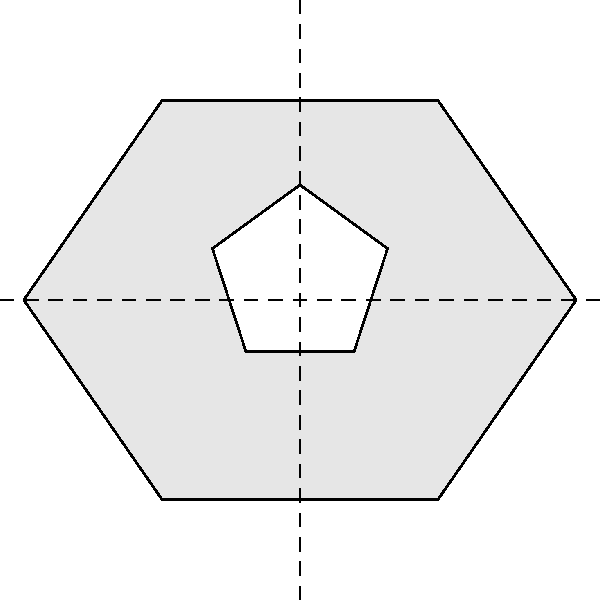As an officer committed to community service, you're analyzing the symmetry of a new police badge design. The badge is a vertically elongated hexagon with a white star in the center. What is the order of the symmetry group for this badge design? To determine the order of the symmetry group, we need to identify all symmetry operations that leave the badge unchanged:

1. Rotational symmetry:
   - The badge has 2-fold rotational symmetry (180° rotation).

2. Reflection symmetry:
   - There are two lines of reflection:
     a. Vertical line through the center
     b. Horizontal line through the center

3. Identity transformation:
   - Leaving the badge unchanged is also a symmetry operation.

To calculate the order of the symmetry group:
- 1 identity transformation
- 1 180° rotation
- 2 reflections (vertical and horizontal)

Therefore, the total number of symmetry operations is 1 + 1 + 2 = 4.

The order of a group is defined as the number of elements in the group. In this case, it's the number of distinct symmetry operations.
Answer: 4 